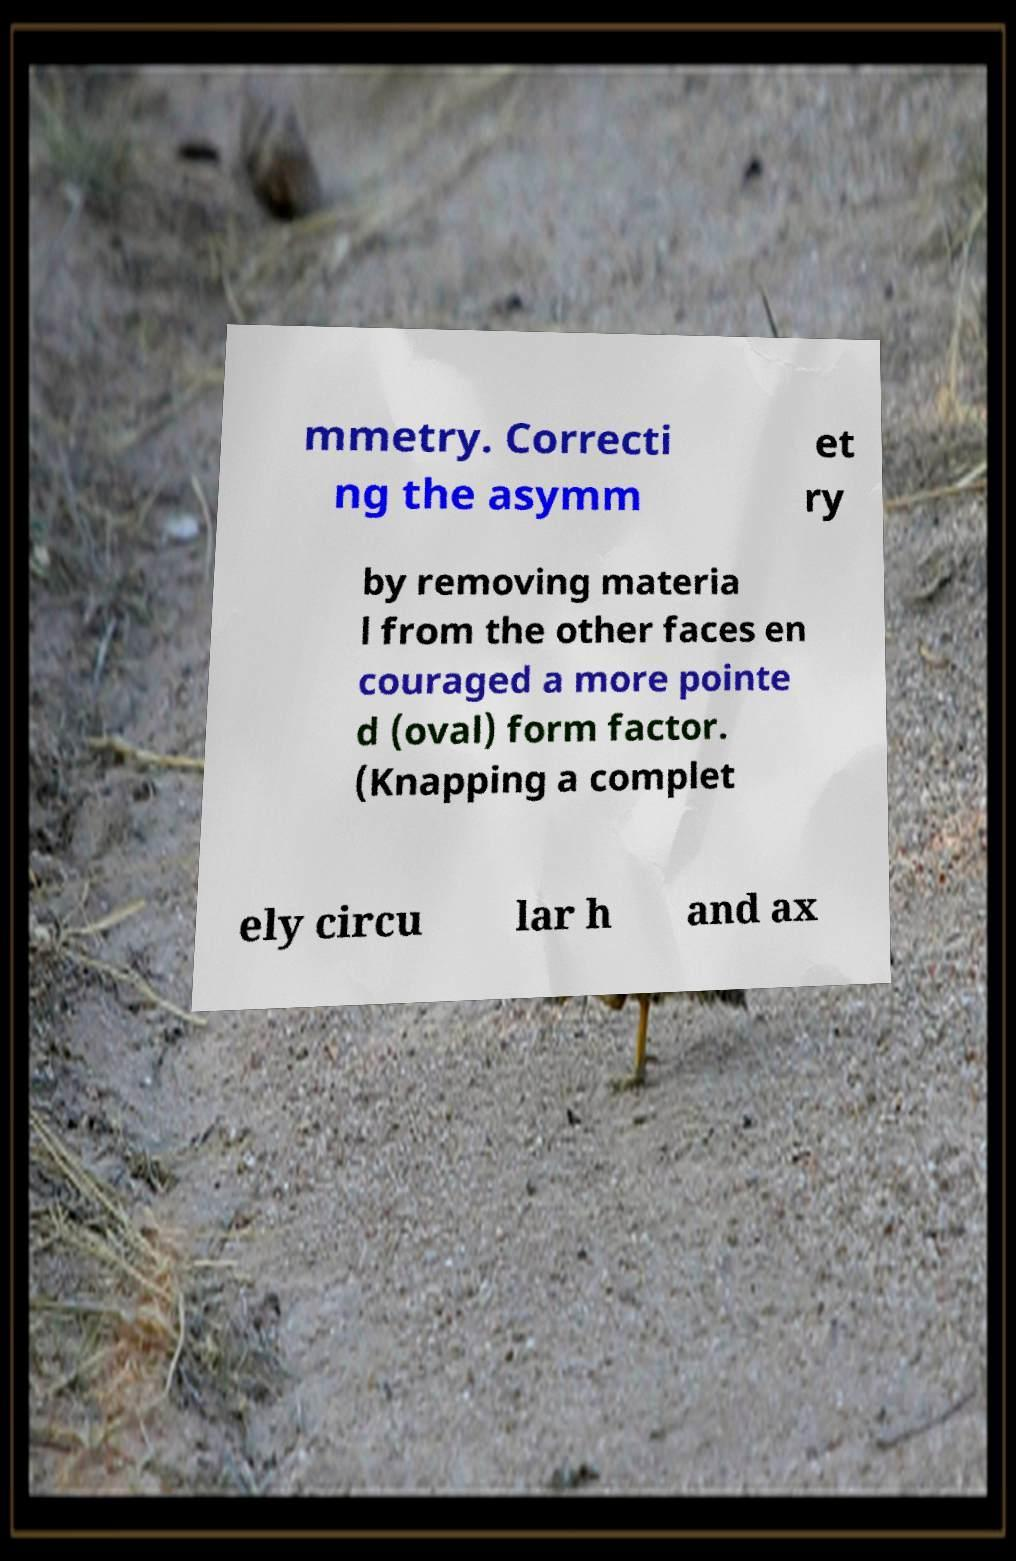For documentation purposes, I need the text within this image transcribed. Could you provide that? mmetry. Correcti ng the asymm et ry by removing materia l from the other faces en couraged a more pointe d (oval) form factor. (Knapping a complet ely circu lar h and ax 